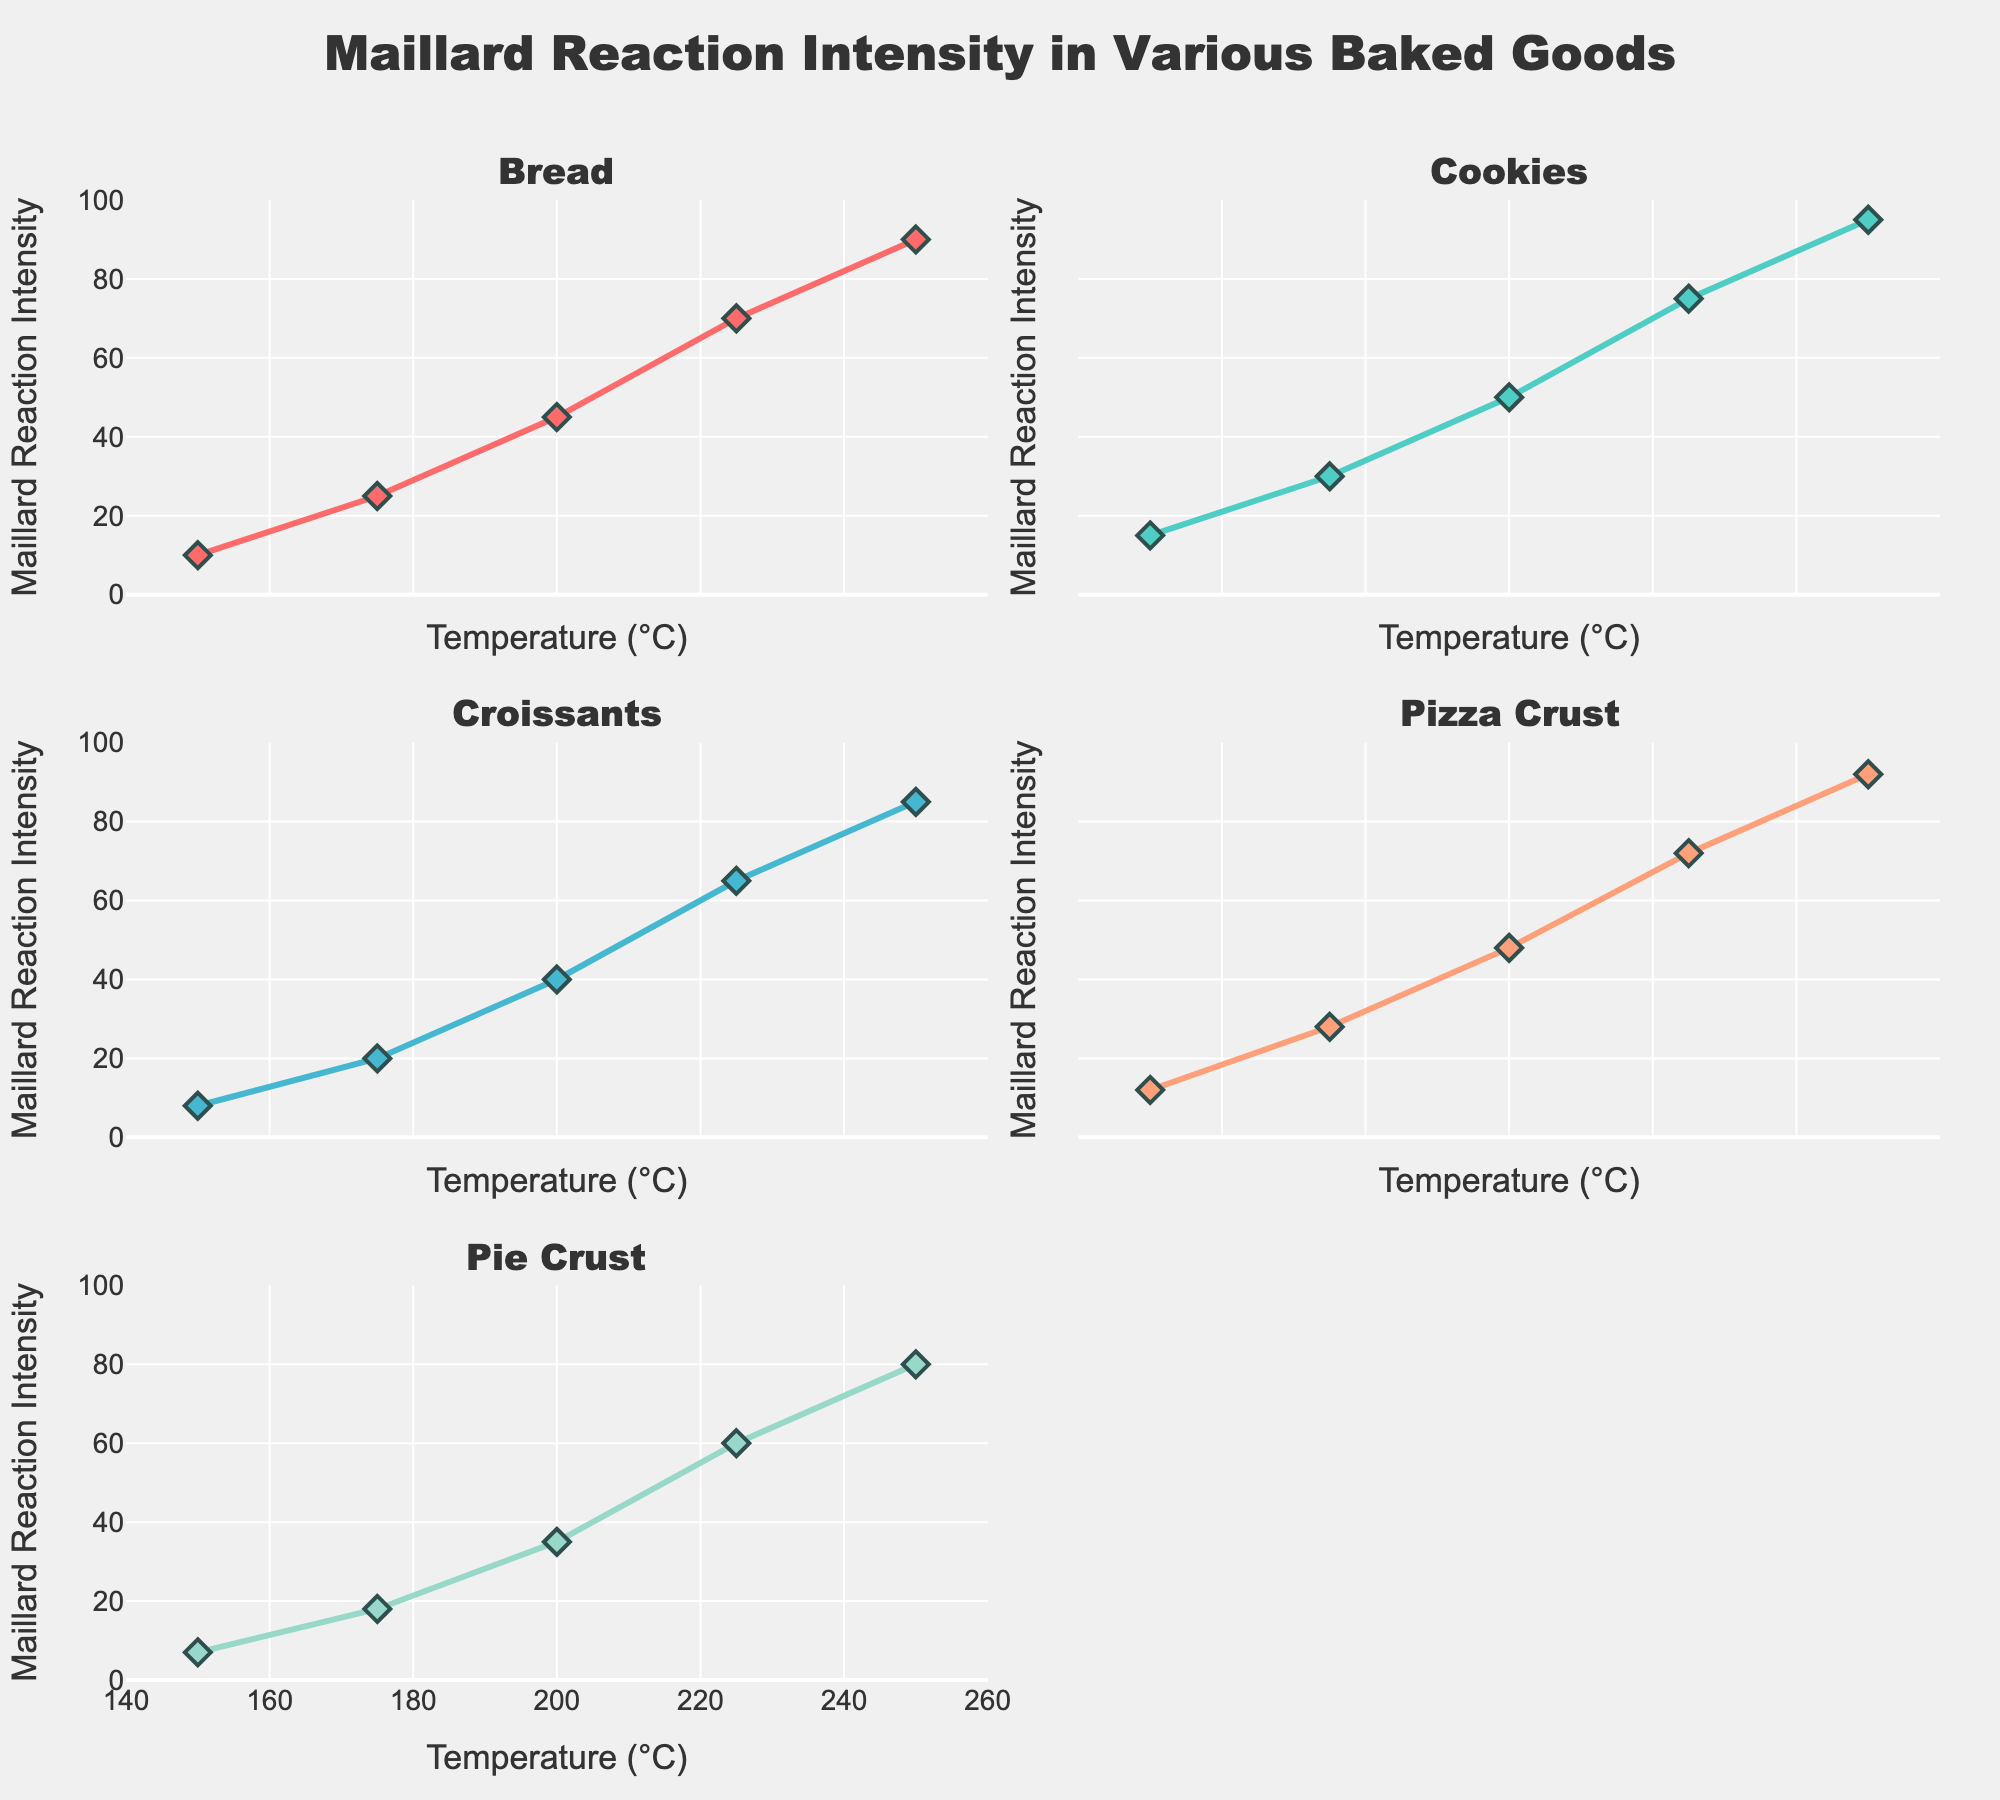what is the title of the figure? The title is located at the top of the figure, summarizing its main topic. It provides context and helps the viewer understand what the data represents
Answer: Cultural Diversity Across Continents How many ethnic groups are displayed in the figure for Africa? The ethnic groups are listed along the y-axis within the Africa subplot. By counting them, we can find the total number.
Answer: 3 Which ethnic group in Oceania has the highest population percentage? Look at the bars in the Oceania subplot and identify the one that extends the farthest to the right. The label of this bar corresponds to the ethnic group with the highest population percentage.
Answer: Polynesian Among the ethnic groups in South America, which has the highest cultural practice score? Check the scatter plot markers on the South America subplot. The ethnic group with the marker positioned furthest to the right on the x-axis has the highest cultural practice score.
Answer: Indigenous Compare the population percentage of the Han Chinese in Asia and the Slavic in Europe. Which one is greater? Locate the Han Chinese bar in the Asia subplot and the Slavic bar in the Europe subplot. Compare their lengths to determine which one is greater.
Answer: Han Chinese What is the combined population percentage of the major ethnic groups in North America? Add the population percentages of the ethnic groups in the North America subplot: Anglo-American (45) + Hispanic (22) + African American (13).
Answer: 80% Which major ethnic group has the lowest cultural practice score in Africa? Examine the scatter plot markers in the Africa subplot. The marker closest to the left on the x-axis represents the ethnic group with the lowest cultural practice score.
Answer: Cushitic What is the average cultural practice score of the Indo-Aryan and Dravidian ethnic groups in Asia? Sum the cultural practice scores of Indo-Aryan (8.3) and Dravidian (7.8) and divide by 2 to find the average.
Answer: 8.05 Is the cultural practice score of the Melanesian group in Oceania greater than the cultural practice score of the Romance group in Europe? Compare the scatter plot markers: Melanesian in Oceania and Romance in Europe. Melanesian's score is 9.0, and Romance's score is 8.1.
Answer: Yes Which contintent displays the largest bar for population percentage? Evaluate the longest bars across all subplots to determine which subplot, corresponding to a continent, has the longest bar. This indicates the continent with the largest population percentage for an ethnic group.
Answer: North America 